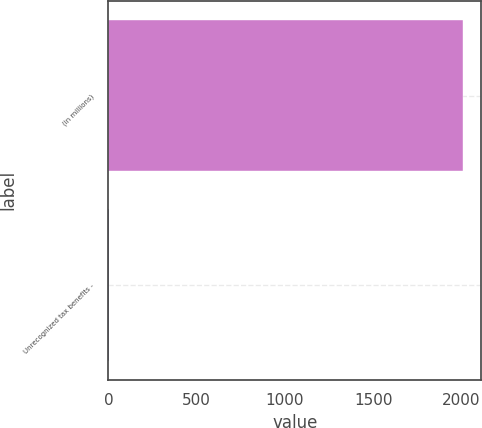<chart> <loc_0><loc_0><loc_500><loc_500><bar_chart><fcel>(in millions)<fcel>Unrecognized tax benefits -<nl><fcel>2011<fcel>5<nl></chart> 